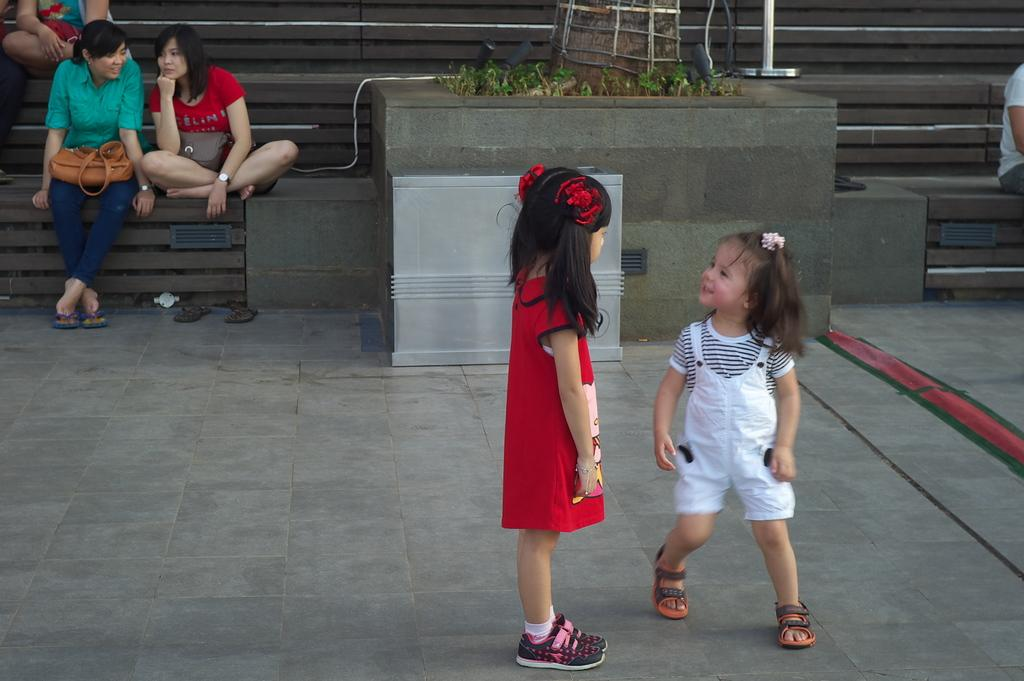How many girls are in the image? There are two small girls in the image. What can be seen in the background of the image? There are steps in the background of the image, and people are sitting on the steps. What is on the stand in the image? Plants are present on the stand in the image. What is the lady on the left side of the image holding? The lady on the left side of the image is holding a bag. What type of company is being advertised on the chair in the image? There is no chair present in the image, and therefore no company being advertised. 